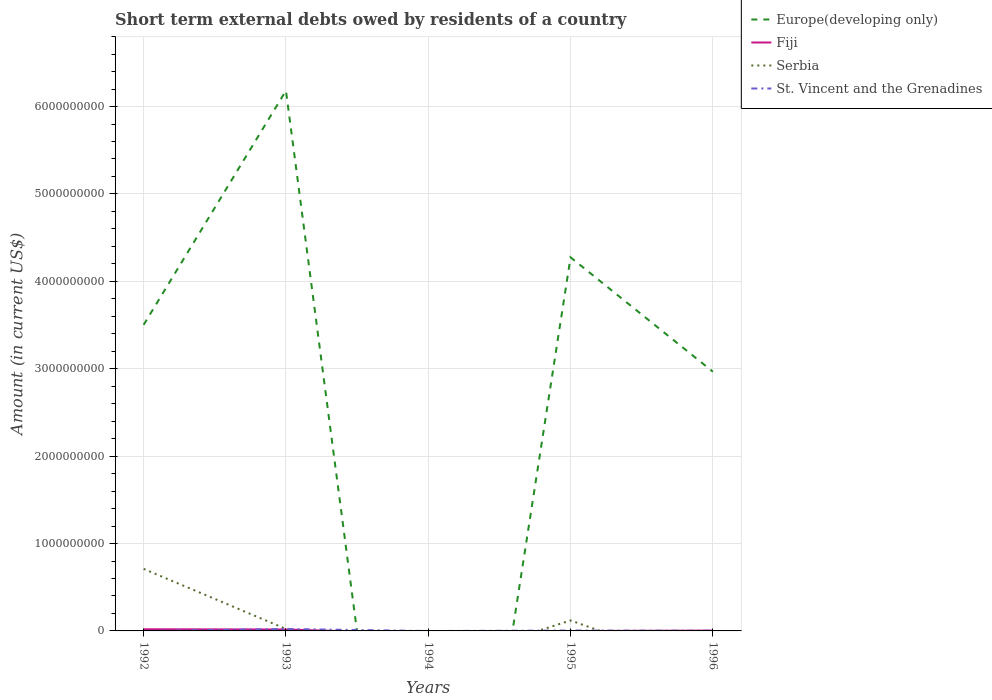How many different coloured lines are there?
Your answer should be compact. 4. Does the line corresponding to St. Vincent and the Grenadines intersect with the line corresponding to Fiji?
Make the answer very short. Yes. Across all years, what is the maximum amount of short-term external debts owed by residents in Fiji?
Make the answer very short. 0. What is the total amount of short-term external debts owed by residents in Europe(developing only) in the graph?
Your answer should be very brief. -2.68e+09. What is the difference between the highest and the second highest amount of short-term external debts owed by residents in Fiji?
Your answer should be compact. 1.91e+07. Is the amount of short-term external debts owed by residents in St. Vincent and the Grenadines strictly greater than the amount of short-term external debts owed by residents in Europe(developing only) over the years?
Your response must be concise. No. How are the legend labels stacked?
Your response must be concise. Vertical. What is the title of the graph?
Keep it short and to the point. Short term external debts owed by residents of a country. Does "Costa Rica" appear as one of the legend labels in the graph?
Ensure brevity in your answer.  No. What is the label or title of the X-axis?
Your answer should be very brief. Years. What is the label or title of the Y-axis?
Ensure brevity in your answer.  Amount (in current US$). What is the Amount (in current US$) in Europe(developing only) in 1992?
Offer a very short reply. 3.50e+09. What is the Amount (in current US$) in Fiji in 1992?
Your response must be concise. 1.91e+07. What is the Amount (in current US$) of Serbia in 1992?
Ensure brevity in your answer.  7.10e+08. What is the Amount (in current US$) of St. Vincent and the Grenadines in 1992?
Give a very brief answer. 0. What is the Amount (in current US$) in Europe(developing only) in 1993?
Ensure brevity in your answer.  6.18e+09. What is the Amount (in current US$) in Fiji in 1993?
Your answer should be compact. 1.62e+07. What is the Amount (in current US$) in Serbia in 1993?
Your answer should be very brief. 2.26e+07. What is the Amount (in current US$) of St. Vincent and the Grenadines in 1993?
Offer a terse response. 2.22e+07. What is the Amount (in current US$) of Europe(developing only) in 1994?
Offer a terse response. 0. What is the Amount (in current US$) of Fiji in 1994?
Ensure brevity in your answer.  0. What is the Amount (in current US$) in Serbia in 1994?
Ensure brevity in your answer.  0. What is the Amount (in current US$) of Europe(developing only) in 1995?
Your answer should be very brief. 4.27e+09. What is the Amount (in current US$) of Fiji in 1995?
Provide a succinct answer. 0. What is the Amount (in current US$) in Serbia in 1995?
Offer a terse response. 1.20e+08. What is the Amount (in current US$) in St. Vincent and the Grenadines in 1995?
Provide a succinct answer. 4.19e+06. What is the Amount (in current US$) of Europe(developing only) in 1996?
Your answer should be very brief. 2.97e+09. What is the Amount (in current US$) of Fiji in 1996?
Provide a short and direct response. 3.51e+06. What is the Amount (in current US$) in St. Vincent and the Grenadines in 1996?
Your answer should be compact. 2.01e+06. Across all years, what is the maximum Amount (in current US$) in Europe(developing only)?
Your answer should be very brief. 6.18e+09. Across all years, what is the maximum Amount (in current US$) in Fiji?
Provide a succinct answer. 1.91e+07. Across all years, what is the maximum Amount (in current US$) in Serbia?
Your answer should be very brief. 7.10e+08. Across all years, what is the maximum Amount (in current US$) of St. Vincent and the Grenadines?
Offer a very short reply. 2.22e+07. Across all years, what is the minimum Amount (in current US$) in St. Vincent and the Grenadines?
Provide a short and direct response. 0. What is the total Amount (in current US$) in Europe(developing only) in the graph?
Your response must be concise. 1.69e+1. What is the total Amount (in current US$) of Fiji in the graph?
Provide a succinct answer. 3.88e+07. What is the total Amount (in current US$) of Serbia in the graph?
Ensure brevity in your answer.  8.52e+08. What is the total Amount (in current US$) of St. Vincent and the Grenadines in the graph?
Keep it short and to the point. 2.84e+07. What is the difference between the Amount (in current US$) of Europe(developing only) in 1992 and that in 1993?
Ensure brevity in your answer.  -2.68e+09. What is the difference between the Amount (in current US$) of Fiji in 1992 and that in 1993?
Keep it short and to the point. 2.86e+06. What is the difference between the Amount (in current US$) of Serbia in 1992 and that in 1993?
Offer a very short reply. 6.87e+08. What is the difference between the Amount (in current US$) of Europe(developing only) in 1992 and that in 1995?
Your answer should be very brief. -7.72e+08. What is the difference between the Amount (in current US$) of Serbia in 1992 and that in 1995?
Offer a very short reply. 5.90e+08. What is the difference between the Amount (in current US$) in Europe(developing only) in 1992 and that in 1996?
Make the answer very short. 5.37e+08. What is the difference between the Amount (in current US$) of Fiji in 1992 and that in 1996?
Offer a terse response. 1.56e+07. What is the difference between the Amount (in current US$) in Europe(developing only) in 1993 and that in 1995?
Keep it short and to the point. 1.91e+09. What is the difference between the Amount (in current US$) in Serbia in 1993 and that in 1995?
Provide a short and direct response. -9.73e+07. What is the difference between the Amount (in current US$) of St. Vincent and the Grenadines in 1993 and that in 1995?
Provide a short and direct response. 1.80e+07. What is the difference between the Amount (in current US$) in Europe(developing only) in 1993 and that in 1996?
Offer a terse response. 3.21e+09. What is the difference between the Amount (in current US$) in Fiji in 1993 and that in 1996?
Provide a succinct answer. 1.27e+07. What is the difference between the Amount (in current US$) of St. Vincent and the Grenadines in 1993 and that in 1996?
Provide a short and direct response. 2.02e+07. What is the difference between the Amount (in current US$) in Europe(developing only) in 1995 and that in 1996?
Make the answer very short. 1.31e+09. What is the difference between the Amount (in current US$) in St. Vincent and the Grenadines in 1995 and that in 1996?
Make the answer very short. 2.18e+06. What is the difference between the Amount (in current US$) of Europe(developing only) in 1992 and the Amount (in current US$) of Fiji in 1993?
Offer a terse response. 3.49e+09. What is the difference between the Amount (in current US$) in Europe(developing only) in 1992 and the Amount (in current US$) in Serbia in 1993?
Your answer should be very brief. 3.48e+09. What is the difference between the Amount (in current US$) of Europe(developing only) in 1992 and the Amount (in current US$) of St. Vincent and the Grenadines in 1993?
Offer a terse response. 3.48e+09. What is the difference between the Amount (in current US$) in Fiji in 1992 and the Amount (in current US$) in Serbia in 1993?
Make the answer very short. -3.53e+06. What is the difference between the Amount (in current US$) of Fiji in 1992 and the Amount (in current US$) of St. Vincent and the Grenadines in 1993?
Offer a terse response. -3.12e+06. What is the difference between the Amount (in current US$) in Serbia in 1992 and the Amount (in current US$) in St. Vincent and the Grenadines in 1993?
Your response must be concise. 6.88e+08. What is the difference between the Amount (in current US$) of Europe(developing only) in 1992 and the Amount (in current US$) of Serbia in 1995?
Your answer should be compact. 3.38e+09. What is the difference between the Amount (in current US$) in Europe(developing only) in 1992 and the Amount (in current US$) in St. Vincent and the Grenadines in 1995?
Your answer should be very brief. 3.50e+09. What is the difference between the Amount (in current US$) of Fiji in 1992 and the Amount (in current US$) of Serbia in 1995?
Your answer should be very brief. -1.01e+08. What is the difference between the Amount (in current US$) of Fiji in 1992 and the Amount (in current US$) of St. Vincent and the Grenadines in 1995?
Provide a short and direct response. 1.49e+07. What is the difference between the Amount (in current US$) of Serbia in 1992 and the Amount (in current US$) of St. Vincent and the Grenadines in 1995?
Your answer should be very brief. 7.06e+08. What is the difference between the Amount (in current US$) of Europe(developing only) in 1992 and the Amount (in current US$) of Fiji in 1996?
Provide a short and direct response. 3.50e+09. What is the difference between the Amount (in current US$) in Europe(developing only) in 1992 and the Amount (in current US$) in St. Vincent and the Grenadines in 1996?
Provide a succinct answer. 3.50e+09. What is the difference between the Amount (in current US$) of Fiji in 1992 and the Amount (in current US$) of St. Vincent and the Grenadines in 1996?
Your answer should be very brief. 1.71e+07. What is the difference between the Amount (in current US$) of Serbia in 1992 and the Amount (in current US$) of St. Vincent and the Grenadines in 1996?
Offer a very short reply. 7.08e+08. What is the difference between the Amount (in current US$) of Europe(developing only) in 1993 and the Amount (in current US$) of Serbia in 1995?
Your answer should be very brief. 6.06e+09. What is the difference between the Amount (in current US$) of Europe(developing only) in 1993 and the Amount (in current US$) of St. Vincent and the Grenadines in 1995?
Give a very brief answer. 6.18e+09. What is the difference between the Amount (in current US$) of Fiji in 1993 and the Amount (in current US$) of Serbia in 1995?
Make the answer very short. -1.04e+08. What is the difference between the Amount (in current US$) of Fiji in 1993 and the Amount (in current US$) of St. Vincent and the Grenadines in 1995?
Offer a very short reply. 1.20e+07. What is the difference between the Amount (in current US$) of Serbia in 1993 and the Amount (in current US$) of St. Vincent and the Grenadines in 1995?
Make the answer very short. 1.84e+07. What is the difference between the Amount (in current US$) in Europe(developing only) in 1993 and the Amount (in current US$) in Fiji in 1996?
Keep it short and to the point. 6.18e+09. What is the difference between the Amount (in current US$) in Europe(developing only) in 1993 and the Amount (in current US$) in St. Vincent and the Grenadines in 1996?
Make the answer very short. 6.18e+09. What is the difference between the Amount (in current US$) of Fiji in 1993 and the Amount (in current US$) of St. Vincent and the Grenadines in 1996?
Offer a very short reply. 1.42e+07. What is the difference between the Amount (in current US$) of Serbia in 1993 and the Amount (in current US$) of St. Vincent and the Grenadines in 1996?
Provide a succinct answer. 2.06e+07. What is the difference between the Amount (in current US$) in Europe(developing only) in 1995 and the Amount (in current US$) in Fiji in 1996?
Offer a terse response. 4.27e+09. What is the difference between the Amount (in current US$) of Europe(developing only) in 1995 and the Amount (in current US$) of St. Vincent and the Grenadines in 1996?
Make the answer very short. 4.27e+09. What is the difference between the Amount (in current US$) in Serbia in 1995 and the Amount (in current US$) in St. Vincent and the Grenadines in 1996?
Offer a very short reply. 1.18e+08. What is the average Amount (in current US$) of Europe(developing only) per year?
Offer a terse response. 3.38e+09. What is the average Amount (in current US$) in Fiji per year?
Make the answer very short. 7.76e+06. What is the average Amount (in current US$) in Serbia per year?
Your response must be concise. 1.70e+08. What is the average Amount (in current US$) of St. Vincent and the Grenadines per year?
Make the answer very short. 5.68e+06. In the year 1992, what is the difference between the Amount (in current US$) in Europe(developing only) and Amount (in current US$) in Fiji?
Give a very brief answer. 3.48e+09. In the year 1992, what is the difference between the Amount (in current US$) of Europe(developing only) and Amount (in current US$) of Serbia?
Your response must be concise. 2.79e+09. In the year 1992, what is the difference between the Amount (in current US$) in Fiji and Amount (in current US$) in Serbia?
Offer a very short reply. -6.91e+08. In the year 1993, what is the difference between the Amount (in current US$) of Europe(developing only) and Amount (in current US$) of Fiji?
Give a very brief answer. 6.16e+09. In the year 1993, what is the difference between the Amount (in current US$) of Europe(developing only) and Amount (in current US$) of Serbia?
Give a very brief answer. 6.16e+09. In the year 1993, what is the difference between the Amount (in current US$) in Europe(developing only) and Amount (in current US$) in St. Vincent and the Grenadines?
Your answer should be very brief. 6.16e+09. In the year 1993, what is the difference between the Amount (in current US$) in Fiji and Amount (in current US$) in Serbia?
Give a very brief answer. -6.39e+06. In the year 1993, what is the difference between the Amount (in current US$) of Fiji and Amount (in current US$) of St. Vincent and the Grenadines?
Provide a succinct answer. -5.98e+06. In the year 1993, what is the difference between the Amount (in current US$) in Serbia and Amount (in current US$) in St. Vincent and the Grenadines?
Keep it short and to the point. 4.10e+05. In the year 1995, what is the difference between the Amount (in current US$) in Europe(developing only) and Amount (in current US$) in Serbia?
Provide a succinct answer. 4.15e+09. In the year 1995, what is the difference between the Amount (in current US$) of Europe(developing only) and Amount (in current US$) of St. Vincent and the Grenadines?
Provide a short and direct response. 4.27e+09. In the year 1995, what is the difference between the Amount (in current US$) in Serbia and Amount (in current US$) in St. Vincent and the Grenadines?
Offer a terse response. 1.16e+08. In the year 1996, what is the difference between the Amount (in current US$) in Europe(developing only) and Amount (in current US$) in Fiji?
Provide a short and direct response. 2.96e+09. In the year 1996, what is the difference between the Amount (in current US$) of Europe(developing only) and Amount (in current US$) of St. Vincent and the Grenadines?
Provide a short and direct response. 2.96e+09. In the year 1996, what is the difference between the Amount (in current US$) in Fiji and Amount (in current US$) in St. Vincent and the Grenadines?
Provide a short and direct response. 1.50e+06. What is the ratio of the Amount (in current US$) of Europe(developing only) in 1992 to that in 1993?
Your answer should be compact. 0.57. What is the ratio of the Amount (in current US$) in Fiji in 1992 to that in 1993?
Offer a very short reply. 1.18. What is the ratio of the Amount (in current US$) in Serbia in 1992 to that in 1993?
Keep it short and to the point. 31.41. What is the ratio of the Amount (in current US$) of Europe(developing only) in 1992 to that in 1995?
Your answer should be very brief. 0.82. What is the ratio of the Amount (in current US$) in Serbia in 1992 to that in 1995?
Ensure brevity in your answer.  5.92. What is the ratio of the Amount (in current US$) in Europe(developing only) in 1992 to that in 1996?
Make the answer very short. 1.18. What is the ratio of the Amount (in current US$) of Fiji in 1992 to that in 1996?
Offer a very short reply. 5.43. What is the ratio of the Amount (in current US$) of Europe(developing only) in 1993 to that in 1995?
Provide a short and direct response. 1.45. What is the ratio of the Amount (in current US$) of Serbia in 1993 to that in 1995?
Provide a succinct answer. 0.19. What is the ratio of the Amount (in current US$) of St. Vincent and the Grenadines in 1993 to that in 1995?
Offer a terse response. 5.29. What is the ratio of the Amount (in current US$) in Europe(developing only) in 1993 to that in 1996?
Provide a succinct answer. 2.08. What is the ratio of the Amount (in current US$) in Fiji in 1993 to that in 1996?
Your answer should be compact. 4.62. What is the ratio of the Amount (in current US$) of St. Vincent and the Grenadines in 1993 to that in 1996?
Your response must be concise. 11.04. What is the ratio of the Amount (in current US$) in Europe(developing only) in 1995 to that in 1996?
Your answer should be very brief. 1.44. What is the ratio of the Amount (in current US$) in St. Vincent and the Grenadines in 1995 to that in 1996?
Make the answer very short. 2.09. What is the difference between the highest and the second highest Amount (in current US$) in Europe(developing only)?
Keep it short and to the point. 1.91e+09. What is the difference between the highest and the second highest Amount (in current US$) of Fiji?
Give a very brief answer. 2.86e+06. What is the difference between the highest and the second highest Amount (in current US$) in Serbia?
Your response must be concise. 5.90e+08. What is the difference between the highest and the second highest Amount (in current US$) of St. Vincent and the Grenadines?
Offer a very short reply. 1.80e+07. What is the difference between the highest and the lowest Amount (in current US$) in Europe(developing only)?
Ensure brevity in your answer.  6.18e+09. What is the difference between the highest and the lowest Amount (in current US$) of Fiji?
Your answer should be very brief. 1.91e+07. What is the difference between the highest and the lowest Amount (in current US$) of Serbia?
Give a very brief answer. 7.10e+08. What is the difference between the highest and the lowest Amount (in current US$) in St. Vincent and the Grenadines?
Keep it short and to the point. 2.22e+07. 